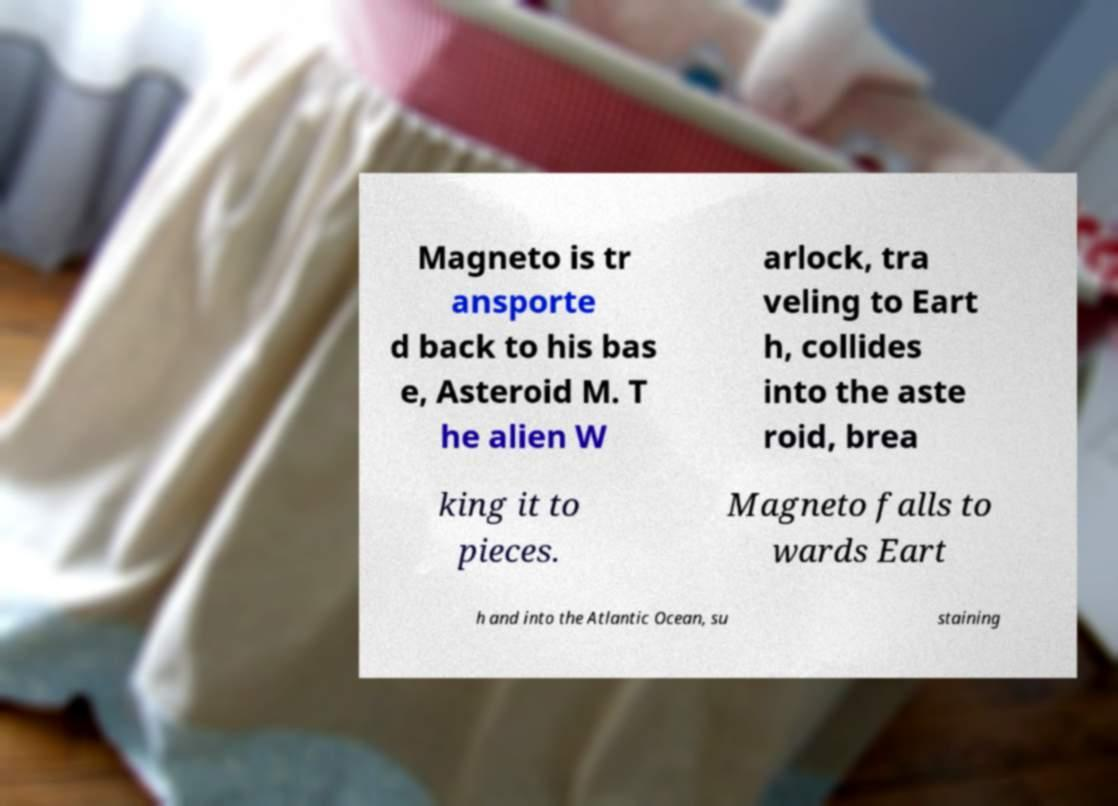What messages or text are displayed in this image? I need them in a readable, typed format. Magneto is tr ansporte d back to his bas e, Asteroid M. T he alien W arlock, tra veling to Eart h, collides into the aste roid, brea king it to pieces. Magneto falls to wards Eart h and into the Atlantic Ocean, su staining 